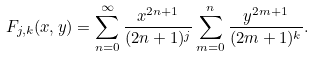<formula> <loc_0><loc_0><loc_500><loc_500>\ F _ { j , k } ( x , y ) = \sum _ { n = 0 } ^ { \infty } \frac { x ^ { 2 n + 1 } } { ( 2 n + 1 ) ^ { j } } \sum _ { m = 0 } ^ { n } \frac { y ^ { 2 m + 1 } } { ( 2 m + 1 ) ^ { k } } .</formula> 